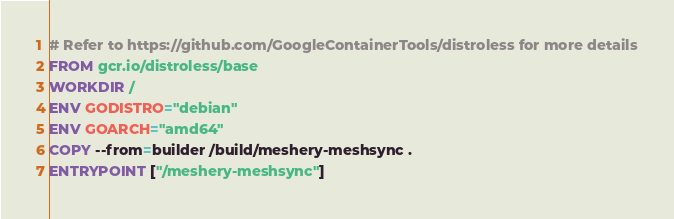<code> <loc_0><loc_0><loc_500><loc_500><_Dockerfile_># Refer to https://github.com/GoogleContainerTools/distroless for more details
FROM gcr.io/distroless/base
WORKDIR /
ENV GODISTRO="debian"
ENV GOARCH="amd64"
COPY --from=builder /build/meshery-meshsync .
ENTRYPOINT ["/meshery-meshsync"]
</code> 